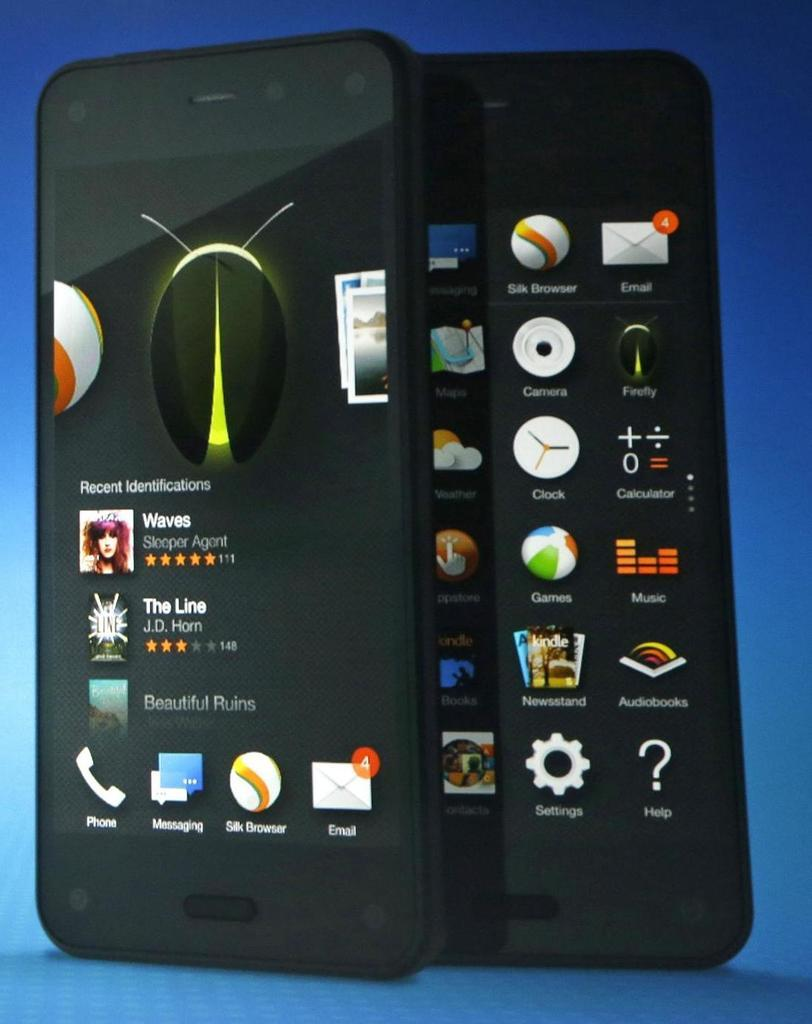<image>
Relay a brief, clear account of the picture shown. Two smartphones are shown on a blue gradient background and they feature different icons on their screens such as "Messaging" and "Recent identifications." 